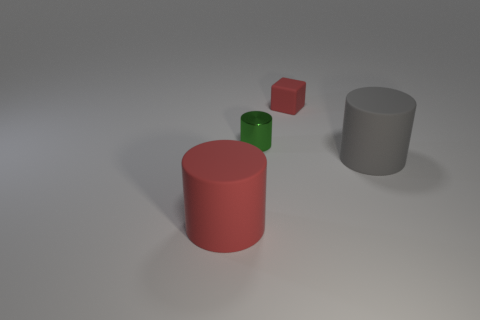Subtract all big matte cylinders. How many cylinders are left? 1 Add 1 big yellow metallic cylinders. How many objects exist? 5 Subtract all green cylinders. How many cylinders are left? 2 Subtract all cubes. How many objects are left? 3 Add 4 gray matte things. How many gray matte things are left? 5 Add 4 large brown rubber balls. How many large brown rubber balls exist? 4 Subtract 0 brown balls. How many objects are left? 4 Subtract all purple cubes. Subtract all red balls. How many cubes are left? 1 Subtract all cylinders. Subtract all big brown balls. How many objects are left? 1 